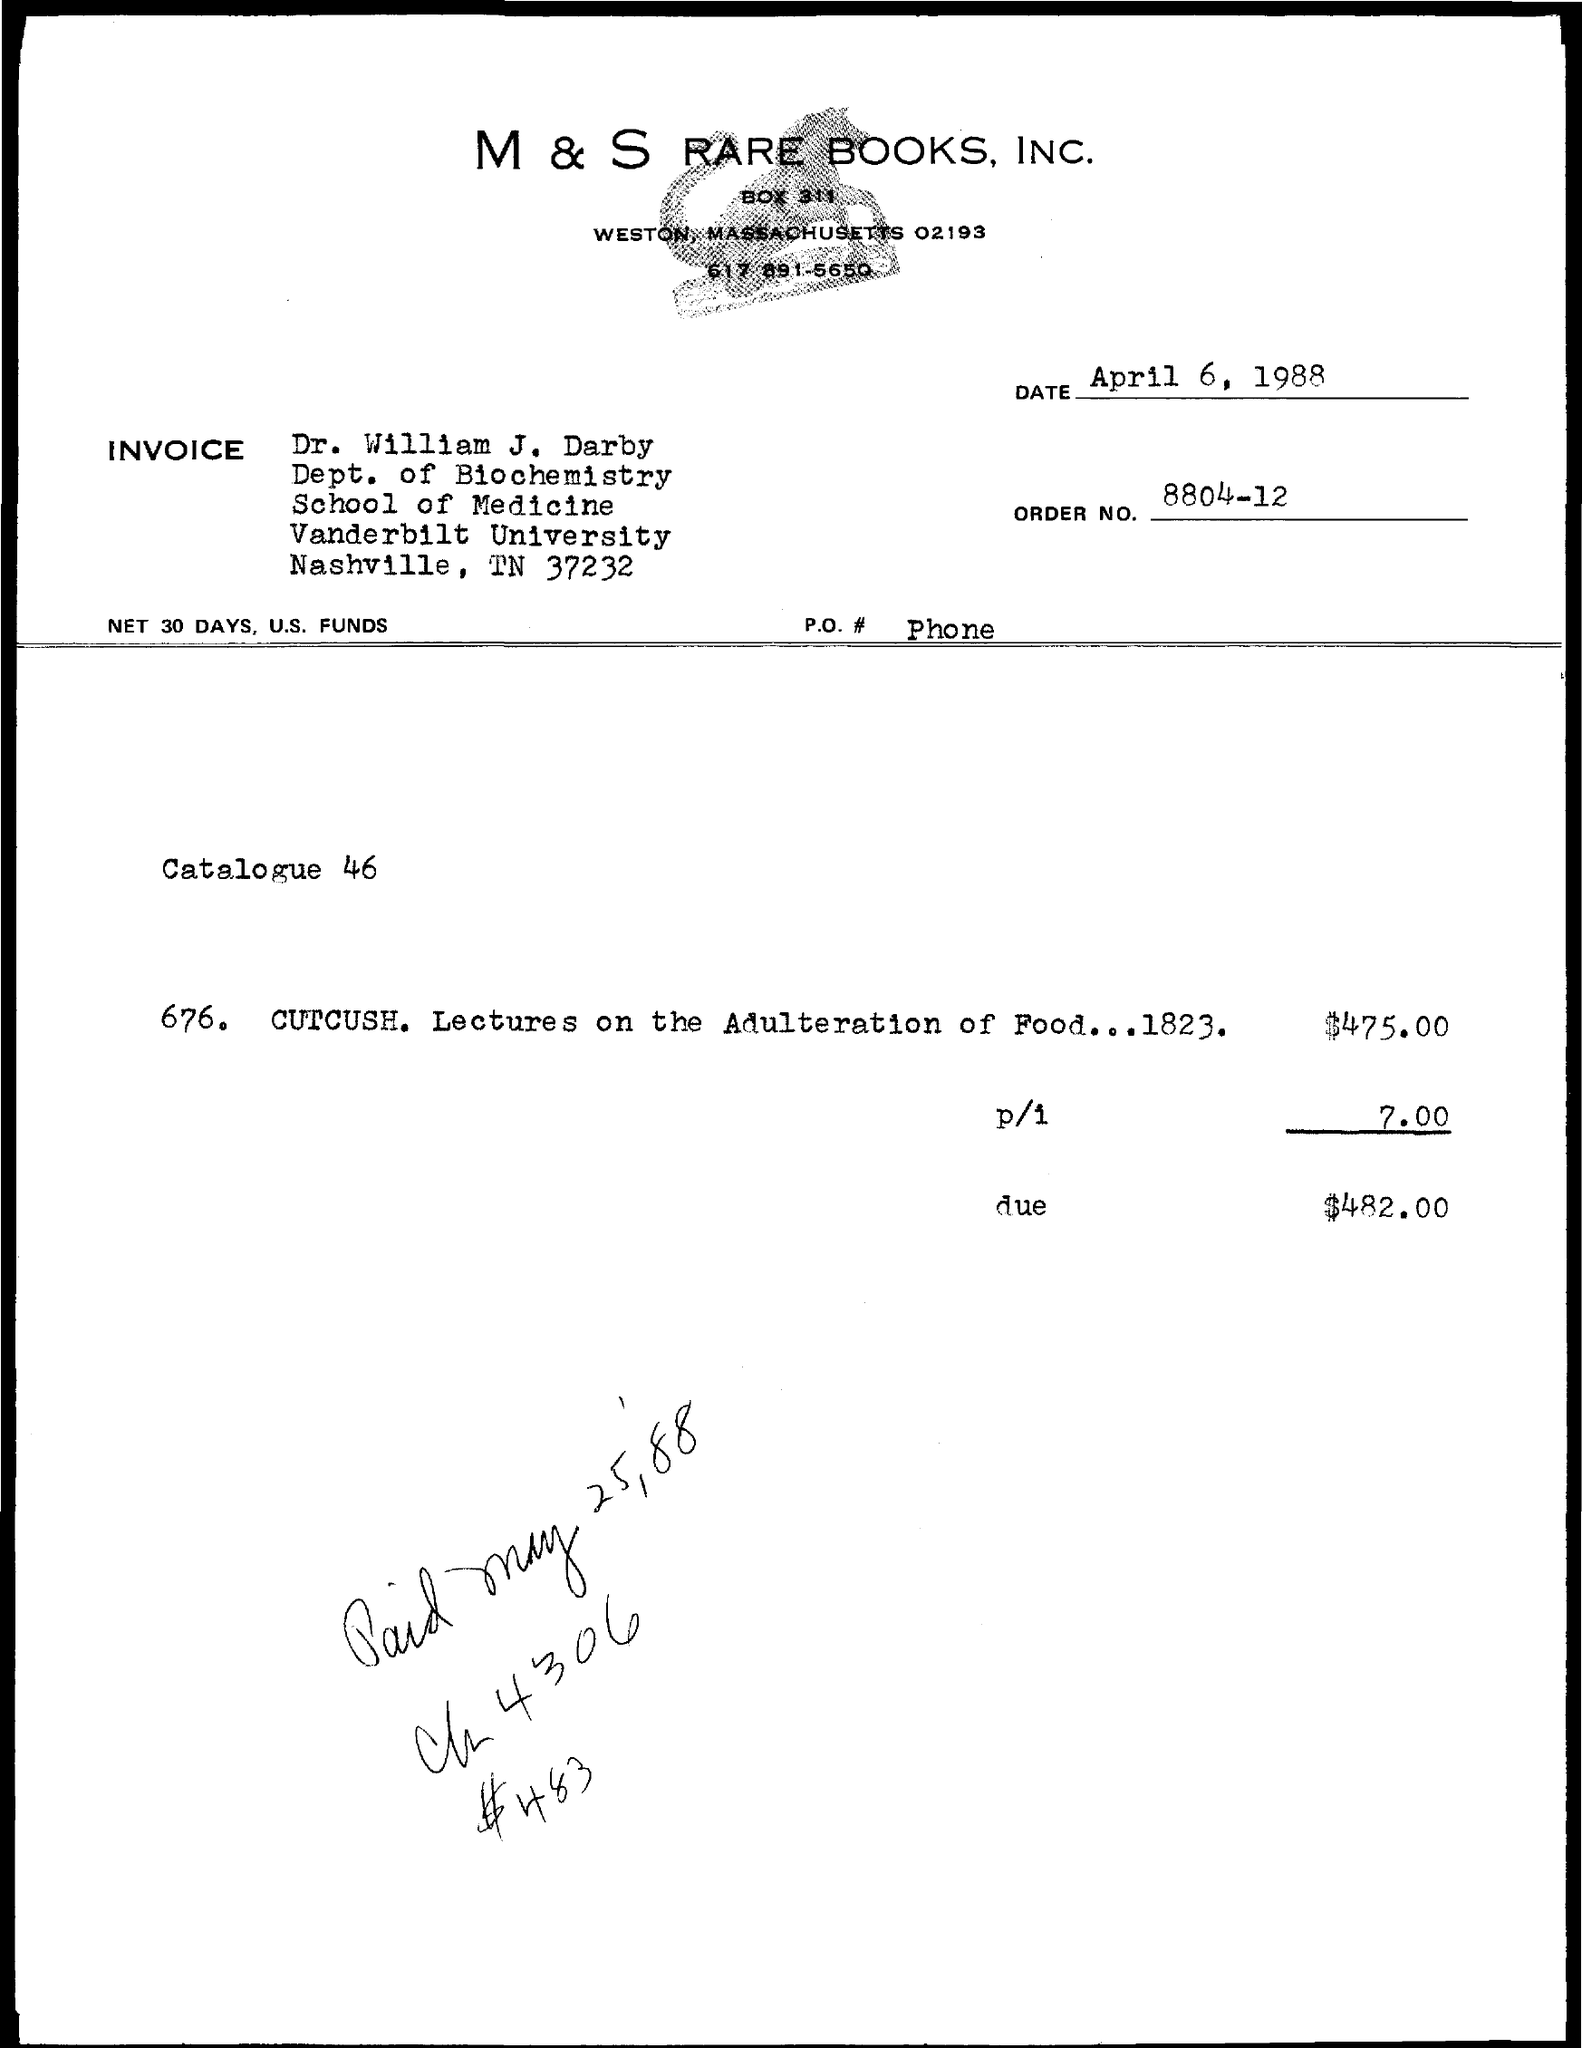Which company is mentioned in the header of the document?
Provide a succinct answer. M & S RARE BOOKS, INC. What is the issued date of the invoice?
Offer a terse response. April 6, 1988. What is the Order No. given in the invoice?
Keep it short and to the point. 8804-12. To whom, the invoice is addressed?
Your answer should be compact. Dr. William J. Darby. In which University, Dr. William J. Darby works?
Offer a very short reply. Vanderbilt University. What is the amount due as per the invoice given?
Your answer should be compact. $482.00. 